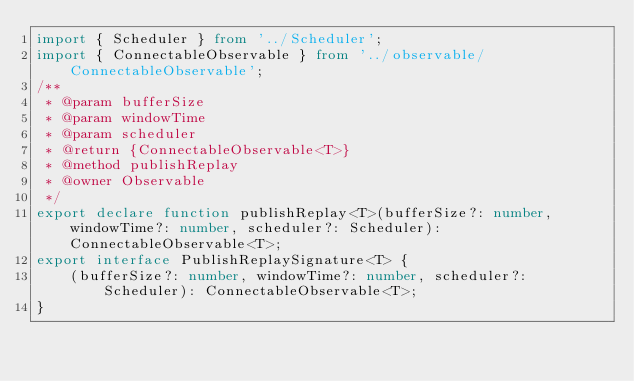Convert code to text. <code><loc_0><loc_0><loc_500><loc_500><_TypeScript_>import { Scheduler } from '../Scheduler';
import { ConnectableObservable } from '../observable/ConnectableObservable';
/**
 * @param bufferSize
 * @param windowTime
 * @param scheduler
 * @return {ConnectableObservable<T>}
 * @method publishReplay
 * @owner Observable
 */
export declare function publishReplay<T>(bufferSize?: number, windowTime?: number, scheduler?: Scheduler): ConnectableObservable<T>;
export interface PublishReplaySignature<T> {
    (bufferSize?: number, windowTime?: number, scheduler?: Scheduler): ConnectableObservable<T>;
}
</code> 